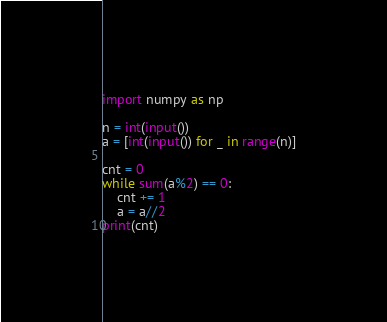<code> <loc_0><loc_0><loc_500><loc_500><_Python_>import numpy as np

n = int(input())
a = [int(input()) for _ in range(n)]

cnt = 0
while sum(a%2) == 0:
    cnt += 1
    a = a//2
print(cnt)</code> 